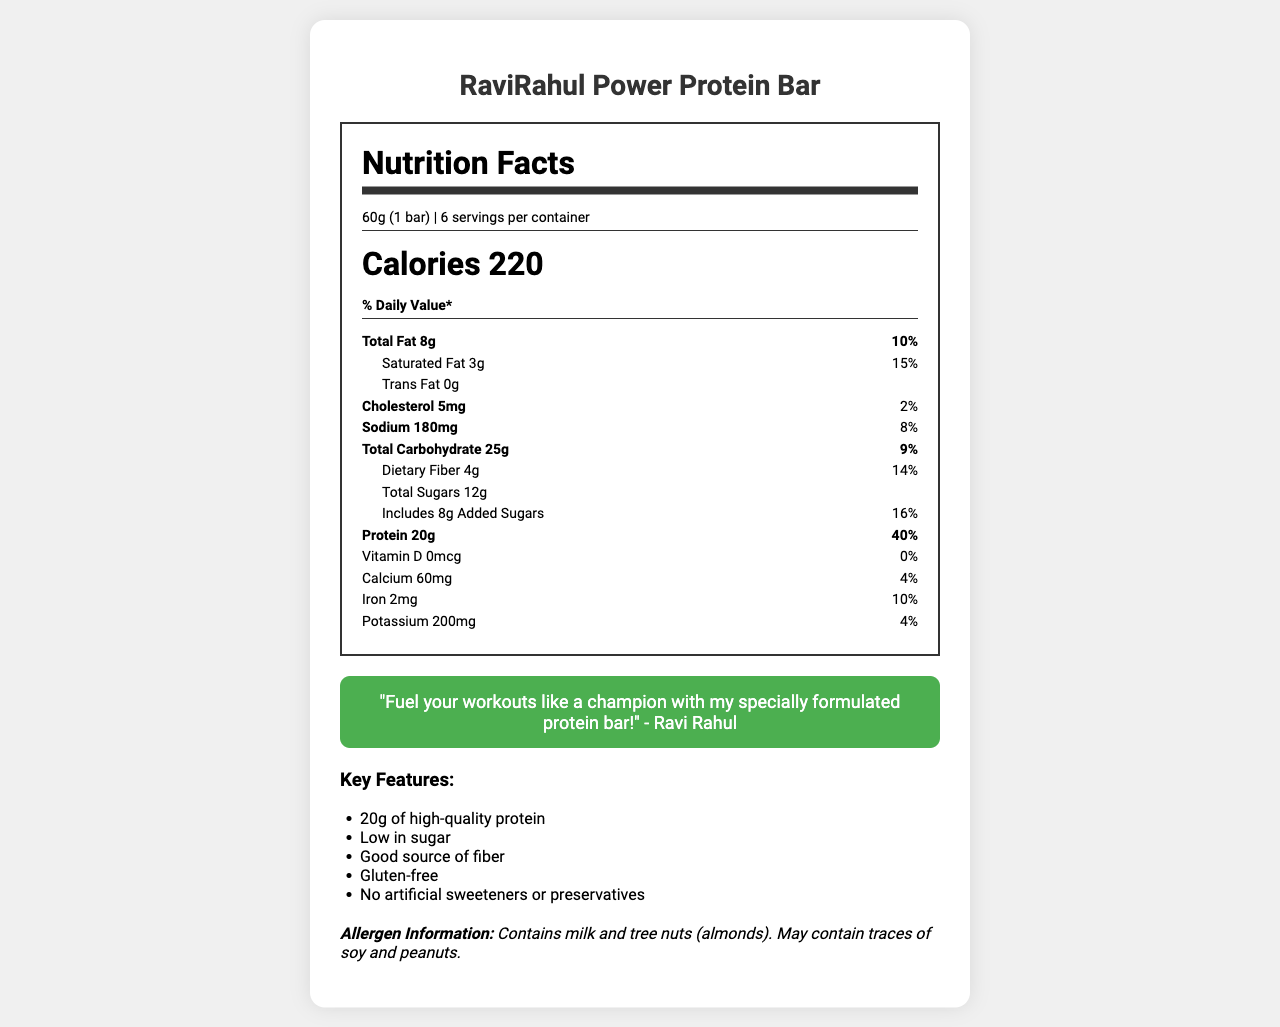What is the serving size of the RaviRahul Power Protein Bar? The Nutrition Facts Label states that the serving size is 60g, which is equivalent to 1 bar.
Answer: 60g (1 bar) What is the calorie count per serving of the RaviRahul Power Protein Bar? The label lists the calories per serving as 220.
Answer: 220 calories How much protein does the RaviRahul Power Protein Bar contain? According to the Nutrition Facts, there are 20 grams of protein per serving.
Answer: 20g What is the dietary fiber content per serving? The label indicates that each serving contains 4 grams of dietary fiber.
Answer: 4g What is the total fat content per serving? The total fat content per serving as listed on the label is 8 grams.
Answer: 8g Which nutrient has the highest % Daily Value per serving? A. Total Fat B. Protein C. Dietary Fiber D. Sodium The % Daily Value for protein is 40%, which is the highest among all the listed nutrients.
Answer: B. Protein How much added sugar is included per serving? A. 6g B. 8g C. 10g D. 12g The label specifies that there are 8 grams of added sugars per serving.
Answer: B. 8g Does the RaviRahul Power Protein Bar contain any trans fats? The Nutrition Facts indicate that the amount of trans fat per serving is 0 grams.
Answer: No Is this protein bar gluten-free? One of the key features listed is that the bar is gluten-free.
Answer: Yes Summarize the key features of the RaviRahul Power Protein Bar. The key features section highlights these points, indicating that the bar is a nutritious option with multiple health benefits.
Answer: High-quality protein, low in sugar, good source of fiber, gluten-free, no artificial sweeteners or preservatives. What is the exact endorsement message from Ravi Rahul on the bar? The endorsement message from Ravi Rahul is presented in quotes within the document.
Answer: "Fuel your workouts like a champion with my specially formulated protein bar!" What are the storage instructions for the RaviRahul Power Protein Bar? The bottom of the label provides the instructions to store the protein bar in a cool, dry place and to avoid direct sunlight.
Answer: Store in a cool, dry place. Avoid direct sunlight. Does the RaviRahul Power Protein Bar contain any calcium? The label shows that the bar contains 60mg of calcium per serving, which is 4% of the Daily Value.
Answer: Yes What is the amount of potassium in one serving of the RaviRahul Power Protein Bar? The Nutrition Facts label lists 200mg of potassium per serving.
Answer: 200mg Which allergens are present in the RaviRahul Power Protein Bar? The allergen information states that the bar contains milk and tree nuts (almonds) and may contain traces of soy and peanuts.
Answer: Milk and tree nuts (almonds). May contain traces of soy and peanuts. Is the RaviRahul Power Protein Bar appropriate for someone with a peanut allergy? It may contain traces of peanuts, as indicated in the allergen information section.
Answer: No What is the protein source in the RaviRahul Power Protein Bar? These are listed among the ingredients on the label.
Answer: Whey protein isolate and pea protein Who endorsed the RaviRahul Power Protein Bar? The endorsement message within the document is attributed to Ravi Rahul.
Answer: Ravi Rahul What is the total carbohydrate content per serving? The label specifies that the total carbohydrate content per serving is 25 grams.
Answer: 25g What is Ravi Rahul trying to convey through his endorsement? A. The bar tastes great B. The bar fuels workouts like a champion C. The bar is budget-friendly D. The bar is all-natural The endorsement specifically mentions "Fuel your workouts like a champion."
Answer: B. The bar fuels workouts like a champion How much iron does one serving contain? The label lists the iron content per serving as 2 milligrams, which is 10% of the Daily Value.
Answer: 2mg What are the recommended uses for the RaviRahul Power Protein Bar? These recommendations are mentioned towards the bottom of the document.
Answer: Enjoy as a pre-workout snack or post-workout recovery fuel. How many servings are there per container? The label indicates 6 servings per container.
Answer: 6 servings What is the main idea of the Nutrition Facts Label for the RaviRahul Power Protein Bar? The document focus is on providing a comprehensive understanding of the nutritional value, key benefits, and other relevant information about the RaviRahul Power Protein Bar.
Answer: The label provides detailed nutritional information about the bar, highlighting its macronutrient profile, key features, and endorsement by Ravi Rahul. It also includes allergen information and recommended uses. What percentage of the Daily Value does the saturated fat content represent? The label indicates that the saturated fat content is 3g, which represents 15% of the Daily Value.
Answer: 15% 